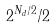Convert formula to latex. <formula><loc_0><loc_0><loc_500><loc_500>2 ^ { N _ { d } / 2 } / 2</formula> 